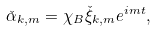<formula> <loc_0><loc_0><loc_500><loc_500>\check { \alpha } _ { k , m } & = \chi _ { B } \check { \xi } _ { k , m } e ^ { i m t } ,</formula> 